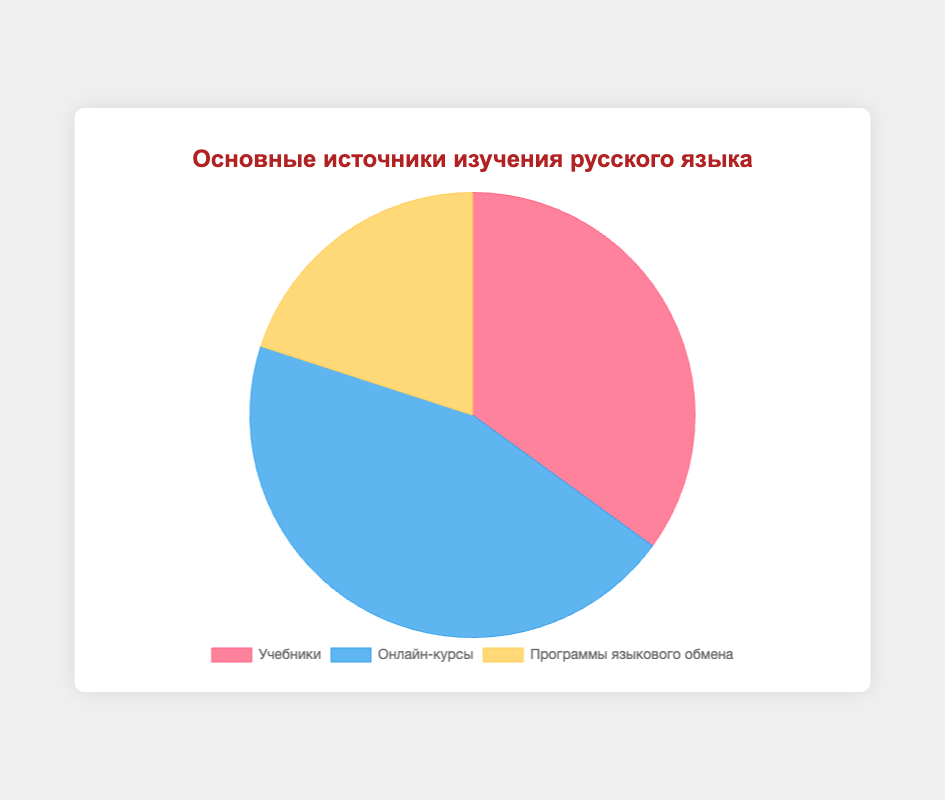What percentage of people use Textbooks and Language Exchange Programs combined as their primary sources of Russian language learning materials? Add the percentage of Textbooks (35%) and Language Exchange Programs (20%). 35 + 20 = 55
Answer: 55% Which category has the highest percentage of users? The pie chart shows three categories: Textbooks, Online Courses, and Language Exchange Programs. Compare their percentages: Textbooks (35%), Online Courses (45%), Language Exchange Programs (20%). Online Courses has the highest percentage.
Answer: Online Courses Which category is visualized with the red color in the pie chart? On the pie chart, the labels correlate with colors: Textbooks (red), Online Courses (blue), Language Exchange Programs (yellow).
Answer: Textbooks If we double the percentage of people who use Language Exchange Programs, how does that compare to those who use Textbooks? Double the percentage of Language Exchange Programs, 20% * 2 = 40%. Compare with Textbooks at 35%. 40% is greater than 35%.
Answer: Greater than What is the percentage difference between the least and the most popular sources of Russian language learning materials? The least popular is Language Exchange Programs at 20%, and the most popular is Online Courses at 45%. Subtract 20% from 45%. 45 - 20 = 25
Answer: 25% By how much percent do Online Courses exceed Language Exchange Programs? Subtract the percentage of Language Exchange Programs (20%) from Online Courses (45%). 45 - 20 = 25
Answer: 25% Is the percentage of people using Online Courses greater than the combined percentage of those using Textbooks and Language Exchange Programs? Summarize Textbooks (35%) and Language Exchange Programs (20%). Compare the sum (55%) to Online Courses (45%). 55% is greater than 45%.
Answer: No Which category has the smallest percentage of users? Check the percentages for each category: Textbooks (35%), Online Courses (45%), Language Exchange Programs (20%). The smallest percentage is for Language Exchange Programs.
Answer: Language Exchange Programs 